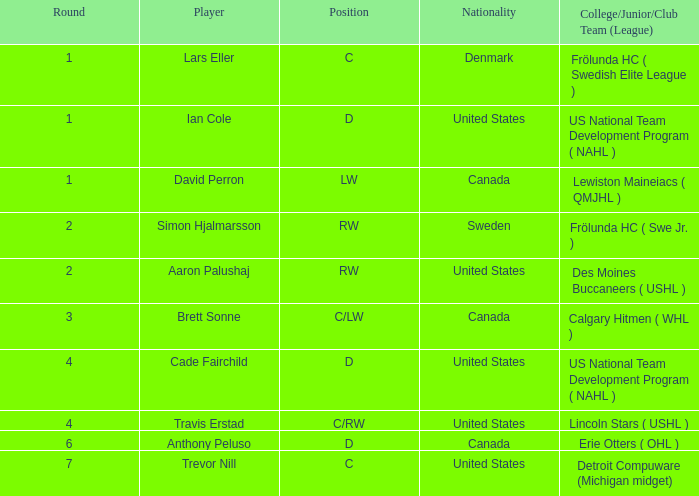In which highest round has ian cole, a position d player from the united states, participated? 1.0. 